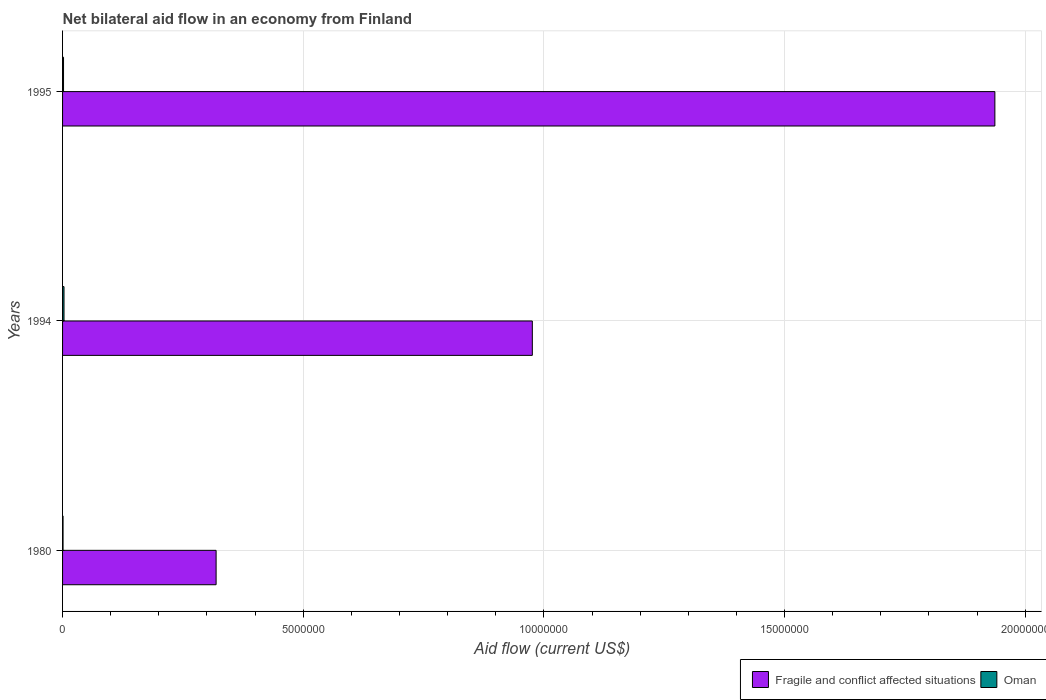How many groups of bars are there?
Make the answer very short. 3. Are the number of bars per tick equal to the number of legend labels?
Your answer should be compact. Yes. Are the number of bars on each tick of the Y-axis equal?
Offer a terse response. Yes. How many bars are there on the 2nd tick from the top?
Ensure brevity in your answer.  2. How many bars are there on the 1st tick from the bottom?
Offer a very short reply. 2. What is the label of the 3rd group of bars from the top?
Give a very brief answer. 1980. What is the net bilateral aid flow in Oman in 1980?
Offer a very short reply. 10000. Across all years, what is the maximum net bilateral aid flow in Fragile and conflict affected situations?
Make the answer very short. 1.94e+07. Across all years, what is the minimum net bilateral aid flow in Oman?
Make the answer very short. 10000. In which year was the net bilateral aid flow in Fragile and conflict affected situations maximum?
Make the answer very short. 1995. In which year was the net bilateral aid flow in Oman minimum?
Your response must be concise. 1980. What is the total net bilateral aid flow in Fragile and conflict affected situations in the graph?
Offer a very short reply. 3.23e+07. What is the difference between the net bilateral aid flow in Fragile and conflict affected situations in 1994 and the net bilateral aid flow in Oman in 1995?
Give a very brief answer. 9.74e+06. What is the average net bilateral aid flow in Fragile and conflict affected situations per year?
Your response must be concise. 1.08e+07. In the year 1980, what is the difference between the net bilateral aid flow in Fragile and conflict affected situations and net bilateral aid flow in Oman?
Your answer should be compact. 3.18e+06. In how many years, is the net bilateral aid flow in Oman greater than 19000000 US$?
Give a very brief answer. 0. What is the ratio of the net bilateral aid flow in Fragile and conflict affected situations in 1980 to that in 1995?
Provide a succinct answer. 0.16. What is the difference between the highest and the second highest net bilateral aid flow in Fragile and conflict affected situations?
Keep it short and to the point. 9.61e+06. In how many years, is the net bilateral aid flow in Fragile and conflict affected situations greater than the average net bilateral aid flow in Fragile and conflict affected situations taken over all years?
Offer a terse response. 1. What does the 1st bar from the top in 1995 represents?
Offer a very short reply. Oman. What does the 2nd bar from the bottom in 1994 represents?
Provide a short and direct response. Oman. Are all the bars in the graph horizontal?
Provide a succinct answer. Yes. How many years are there in the graph?
Offer a terse response. 3. Does the graph contain any zero values?
Provide a succinct answer. No. Does the graph contain grids?
Your answer should be compact. Yes. Where does the legend appear in the graph?
Offer a very short reply. Bottom right. How are the legend labels stacked?
Provide a succinct answer. Horizontal. What is the title of the graph?
Your response must be concise. Net bilateral aid flow in an economy from Finland. What is the label or title of the X-axis?
Your answer should be very brief. Aid flow (current US$). What is the Aid flow (current US$) in Fragile and conflict affected situations in 1980?
Provide a succinct answer. 3.19e+06. What is the Aid flow (current US$) in Oman in 1980?
Your answer should be compact. 10000. What is the Aid flow (current US$) in Fragile and conflict affected situations in 1994?
Provide a short and direct response. 9.76e+06. What is the Aid flow (current US$) of Oman in 1994?
Give a very brief answer. 3.00e+04. What is the Aid flow (current US$) in Fragile and conflict affected situations in 1995?
Give a very brief answer. 1.94e+07. What is the Aid flow (current US$) of Oman in 1995?
Provide a succinct answer. 2.00e+04. Across all years, what is the maximum Aid flow (current US$) of Fragile and conflict affected situations?
Keep it short and to the point. 1.94e+07. Across all years, what is the maximum Aid flow (current US$) of Oman?
Provide a short and direct response. 3.00e+04. Across all years, what is the minimum Aid flow (current US$) of Fragile and conflict affected situations?
Keep it short and to the point. 3.19e+06. Across all years, what is the minimum Aid flow (current US$) in Oman?
Offer a terse response. 10000. What is the total Aid flow (current US$) of Fragile and conflict affected situations in the graph?
Ensure brevity in your answer.  3.23e+07. What is the difference between the Aid flow (current US$) of Fragile and conflict affected situations in 1980 and that in 1994?
Provide a succinct answer. -6.57e+06. What is the difference between the Aid flow (current US$) of Oman in 1980 and that in 1994?
Ensure brevity in your answer.  -2.00e+04. What is the difference between the Aid flow (current US$) of Fragile and conflict affected situations in 1980 and that in 1995?
Your answer should be very brief. -1.62e+07. What is the difference between the Aid flow (current US$) in Fragile and conflict affected situations in 1994 and that in 1995?
Offer a terse response. -9.61e+06. What is the difference between the Aid flow (current US$) in Oman in 1994 and that in 1995?
Your answer should be compact. 10000. What is the difference between the Aid flow (current US$) of Fragile and conflict affected situations in 1980 and the Aid flow (current US$) of Oman in 1994?
Ensure brevity in your answer.  3.16e+06. What is the difference between the Aid flow (current US$) in Fragile and conflict affected situations in 1980 and the Aid flow (current US$) in Oman in 1995?
Provide a succinct answer. 3.17e+06. What is the difference between the Aid flow (current US$) of Fragile and conflict affected situations in 1994 and the Aid flow (current US$) of Oman in 1995?
Keep it short and to the point. 9.74e+06. What is the average Aid flow (current US$) in Fragile and conflict affected situations per year?
Provide a succinct answer. 1.08e+07. In the year 1980, what is the difference between the Aid flow (current US$) in Fragile and conflict affected situations and Aid flow (current US$) in Oman?
Offer a very short reply. 3.18e+06. In the year 1994, what is the difference between the Aid flow (current US$) of Fragile and conflict affected situations and Aid flow (current US$) of Oman?
Ensure brevity in your answer.  9.73e+06. In the year 1995, what is the difference between the Aid flow (current US$) of Fragile and conflict affected situations and Aid flow (current US$) of Oman?
Offer a very short reply. 1.94e+07. What is the ratio of the Aid flow (current US$) of Fragile and conflict affected situations in 1980 to that in 1994?
Make the answer very short. 0.33. What is the ratio of the Aid flow (current US$) in Oman in 1980 to that in 1994?
Provide a short and direct response. 0.33. What is the ratio of the Aid flow (current US$) in Fragile and conflict affected situations in 1980 to that in 1995?
Your response must be concise. 0.16. What is the ratio of the Aid flow (current US$) of Fragile and conflict affected situations in 1994 to that in 1995?
Ensure brevity in your answer.  0.5. What is the difference between the highest and the second highest Aid flow (current US$) of Fragile and conflict affected situations?
Provide a succinct answer. 9.61e+06. What is the difference between the highest and the lowest Aid flow (current US$) in Fragile and conflict affected situations?
Offer a terse response. 1.62e+07. What is the difference between the highest and the lowest Aid flow (current US$) in Oman?
Your response must be concise. 2.00e+04. 